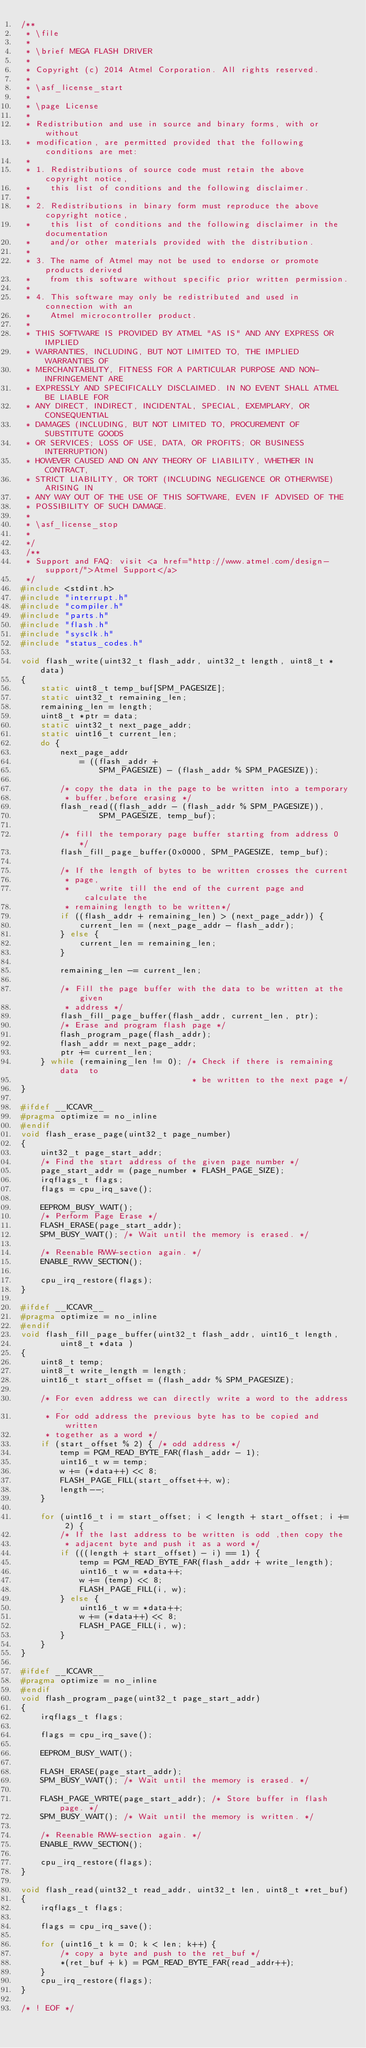<code> <loc_0><loc_0><loc_500><loc_500><_C_>/**
 * \file
 *
 * \brief MEGA FLASH DRIVER
 *
 * Copyright (c) 2014 Atmel Corporation. All rights reserved.
 *
 * \asf_license_start
 *
 * \page License
 *
 * Redistribution and use in source and binary forms, with or without
 * modification, are permitted provided that the following conditions are met:
 *
 * 1. Redistributions of source code must retain the above copyright notice,
 *    this list of conditions and the following disclaimer.
 *
 * 2. Redistributions in binary form must reproduce the above copyright notice,
 *    this list of conditions and the following disclaimer in the documentation
 *    and/or other materials provided with the distribution.
 *
 * 3. The name of Atmel may not be used to endorse or promote products derived
 *    from this software without specific prior written permission.
 *
 * 4. This software may only be redistributed and used in connection with an
 *    Atmel microcontroller product.
 *
 * THIS SOFTWARE IS PROVIDED BY ATMEL "AS IS" AND ANY EXPRESS OR IMPLIED
 * WARRANTIES, INCLUDING, BUT NOT LIMITED TO, THE IMPLIED WARRANTIES OF
 * MERCHANTABILITY, FITNESS FOR A PARTICULAR PURPOSE AND NON-INFRINGEMENT ARE
 * EXPRESSLY AND SPECIFICALLY DISCLAIMED. IN NO EVENT SHALL ATMEL BE LIABLE FOR
 * ANY DIRECT, INDIRECT, INCIDENTAL, SPECIAL, EXEMPLARY, OR CONSEQUENTIAL
 * DAMAGES (INCLUDING, BUT NOT LIMITED TO, PROCUREMENT OF SUBSTITUTE GOODS
 * OR SERVICES; LOSS OF USE, DATA, OR PROFITS; OR BUSINESS INTERRUPTION)
 * HOWEVER CAUSED AND ON ANY THEORY OF LIABILITY, WHETHER IN CONTRACT,
 * STRICT LIABILITY, OR TORT (INCLUDING NEGLIGENCE OR OTHERWISE) ARISING IN
 * ANY WAY OUT OF THE USE OF THIS SOFTWARE, EVEN IF ADVISED OF THE
 * POSSIBILITY OF SUCH DAMAGE.
 *
 * \asf_license_stop
 *
 */
 /**
 * Support and FAQ: visit <a href="http://www.atmel.com/design-support/">Atmel Support</a>
 */
#include <stdint.h>
#include "interrupt.h"
#include "compiler.h"
#include "parts.h"
#include "flash.h"
#include "sysclk.h"
#include "status_codes.h"

void flash_write(uint32_t flash_addr, uint32_t length, uint8_t *data)
{
	static uint8_t temp_buf[SPM_PAGESIZE];
	static uint32_t remaining_len;
	remaining_len = length;
	uint8_t *ptr = data;
	static uint32_t next_page_addr;
	static uint16_t current_len;
	do {
		next_page_addr
			= ((flash_addr +
				SPM_PAGESIZE) - (flash_addr % SPM_PAGESIZE));

		/* copy the data in the page to be written into a temporary
		 * buffer,before erasing */
		flash_read((flash_addr - (flash_addr % SPM_PAGESIZE)),
				SPM_PAGESIZE, temp_buf);

		/* fill the temporary page buffer starting from address 0 */
		flash_fill_page_buffer(0x0000, SPM_PAGESIZE, temp_buf);

		/* If the length of bytes to be written crosses the current
		 * page,
		 *      write till the end of the current page and calculate the
		 * remaining length to be written*/
		if ((flash_addr + remaining_len) > (next_page_addr)) {
			current_len = (next_page_addr - flash_addr);
		} else {
			current_len = remaining_len;
		}

		remaining_len -= current_len;

		/* Fill the page buffer with the data to be written at the given
		 * address */
		flash_fill_page_buffer(flash_addr, current_len, ptr);
		/* Erase and program flash page */
		flash_program_page(flash_addr);
		flash_addr = next_page_addr;
		ptr += current_len;
	} while (remaining_len != 0); /* Check if there is remaining  data  to
	                               * be written to the next page */
}

#ifdef __ICCAVR__
#pragma optimize = no_inline
#endif
void flash_erase_page(uint32_t page_number)
{
	uint32_t page_start_addr;
	/* Find the start address of the given page number */
	page_start_addr = (page_number * FLASH_PAGE_SIZE);
	irqflags_t flags;
	flags = cpu_irq_save();

	EEPROM_BUSY_WAIT();
	/* Perform Page Erase */
	FLASH_ERASE(page_start_addr);
	SPM_BUSY_WAIT(); /* Wait until the memory is erased. */

	/* Reenable RWW-section again. */
	ENABLE_RWW_SECTION();

	cpu_irq_restore(flags);
}

#ifdef __ICCAVR__
#pragma optimize = no_inline
#endif
void flash_fill_page_buffer(uint32_t flash_addr, uint16_t length,
		uint8_t *data )
{
	uint8_t temp;
	uint8_t write_length = length;
	uint16_t start_offset = (flash_addr % SPM_PAGESIZE);

	/* For even address we can directly write a word to the address.
	 * For odd address the previous byte has to be copied and written
	 * together as a word */
	if (start_offset % 2) { /* odd address */
		temp = PGM_READ_BYTE_FAR(flash_addr - 1);
		uint16_t w = temp;
		w += (*data++) << 8;
		FLASH_PAGE_FILL(start_offset++, w);
		length--;
	}

	for (uint16_t i = start_offset; i < length + start_offset; i += 2) {
		/* If the last address to be written is odd ,then copy the
		 * adjacent byte and push it as a word */
		if (((length + start_offset) - i) == 1) {
			temp = PGM_READ_BYTE_FAR(flash_addr + write_length);
			uint16_t w = *data++;
			w += (temp) << 8;
			FLASH_PAGE_FILL(i, w);
		} else {
			uint16_t w = *data++;
			w += (*data++) << 8;
			FLASH_PAGE_FILL(i, w);
		}
	}
}

#ifdef __ICCAVR__
#pragma optimize = no_inline
#endif
void flash_program_page(uint32_t page_start_addr)
{
	irqflags_t flags;

	flags = cpu_irq_save();

	EEPROM_BUSY_WAIT();

	FLASH_ERASE(page_start_addr);
	SPM_BUSY_WAIT(); /* Wait until the memory is erased. */

	FLASH_PAGE_WRITE(page_start_addr); /* Store buffer in flash page. */
	SPM_BUSY_WAIT(); /* Wait until the memory is written. */

	/* Reenable RWW-section again. */
	ENABLE_RWW_SECTION();

	cpu_irq_restore(flags);
}

void flash_read(uint32_t read_addr, uint32_t len, uint8_t *ret_buf)
{
	irqflags_t flags;

	flags = cpu_irq_save();

	for (uint16_t k = 0; k < len; k++) {
		/* copy a byte and push to the ret_buf */
		*(ret_buf + k) = PGM_READ_BYTE_FAR(read_addr++);
	}
	cpu_irq_restore(flags);
}

/* ! EOF */
</code> 